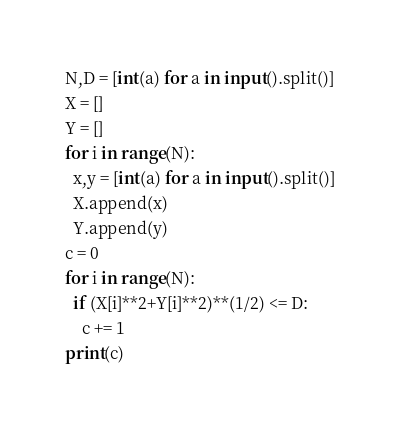Convert code to text. <code><loc_0><loc_0><loc_500><loc_500><_Python_>N,D = [int(a) for a in input().split()]
X = []
Y = []
for i in range(N):
  x,y = [int(a) for a in input().split()]
  X.append(x)
  Y.append(y)
c = 0
for i in range(N):
  if (X[i]**2+Y[i]**2)**(1/2) <= D:
    c += 1
print(c)</code> 